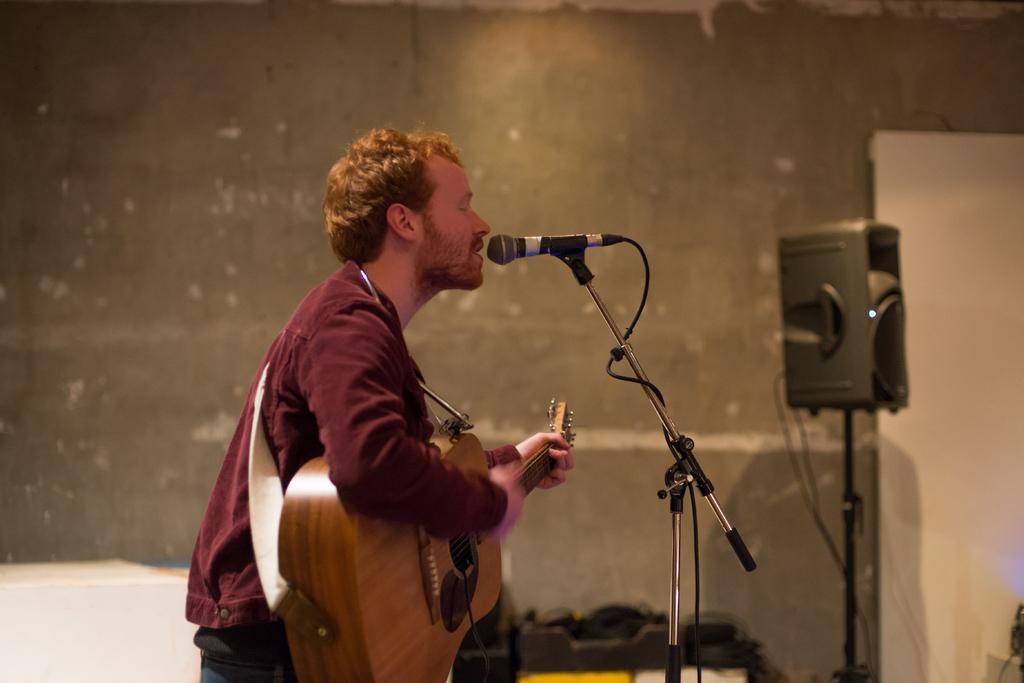Could you give a brief overview of what you see in this image? In this picture one man is standing wearing a maroon shirt and playing a guitar and singing in front of the microphone and beside him there is one speaker at the right corner and a door and there is a one big door. 